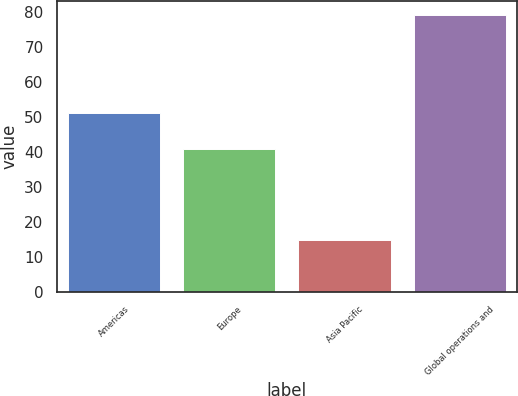<chart> <loc_0><loc_0><loc_500><loc_500><bar_chart><fcel>Americas<fcel>Europe<fcel>Asia Pacific<fcel>Global operations and<nl><fcel>51<fcel>40.8<fcel>14.8<fcel>79.1<nl></chart> 